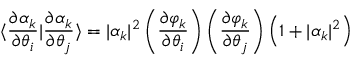<formula> <loc_0><loc_0><loc_500><loc_500>\langle \frac { \partial \alpha _ { k } } { \partial \theta _ { i } } | \frac { \partial \alpha _ { k } } { \partial \theta _ { j } } \rangle = | \alpha _ { k } | ^ { 2 } \left ( \frac { \partial \varphi _ { k } } { \partial \theta _ { i } } \right ) \left ( \frac { \partial \varphi _ { k } } { \partial \theta _ { j } } \right ) \left ( 1 + | \alpha _ { k } | ^ { 2 } \right )</formula> 